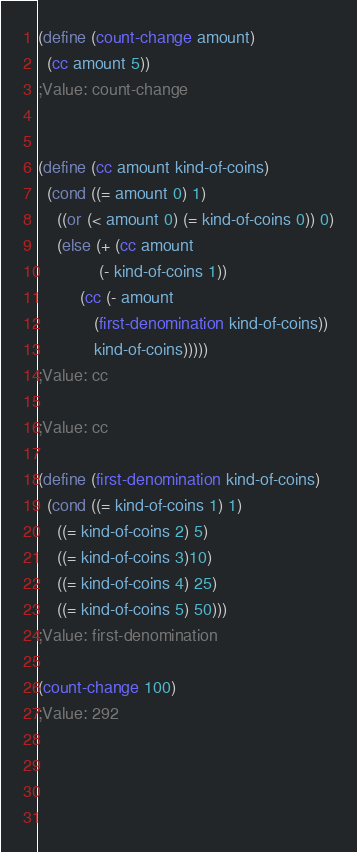Convert code to text. <code><loc_0><loc_0><loc_500><loc_500><_Scheme_>
(define (count-change amount)
  (cc amount 5))
;Value: count-change


(define (cc amount kind-of-coins)
  (cond ((= amount 0) 1)
	((or (< amount 0) (= kind-of-coins 0)) 0)
	(else (+ (cc amount
		     (- kind-of-coins 1))
		 (cc (- amount 
			(first-denomination kind-of-coins))
			kind-of-coins)))))
;Value: cc

;Value: cc

(define (first-denomination kind-of-coins)
  (cond ((= kind-of-coins 1) 1)
	((= kind-of-coins 2) 5)
	((= kind-of-coins 3)10)
	((= kind-of-coins 4) 25)
	((= kind-of-coins 5) 50)))
;Value: first-denomination

(count-change 100)
;Value: 292



		     </code> 